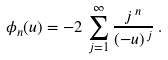<formula> <loc_0><loc_0><loc_500><loc_500>\phi _ { n } ( u ) = - 2 \, \sum _ { j = 1 } ^ { \infty } { \frac { j ^ { \, n } } { ( - u ) ^ { \, j } } } \, .</formula> 